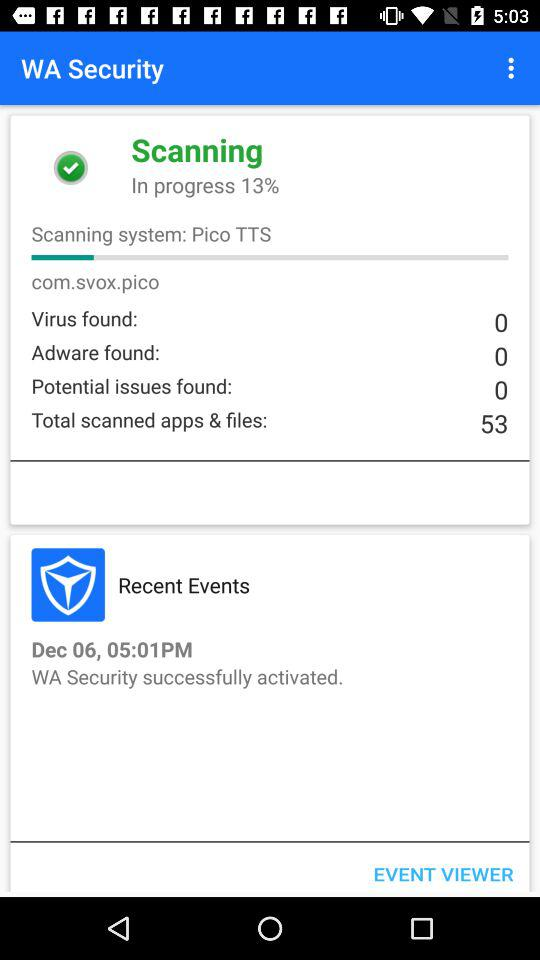How much scanning is done? The scanning is 13% done. 